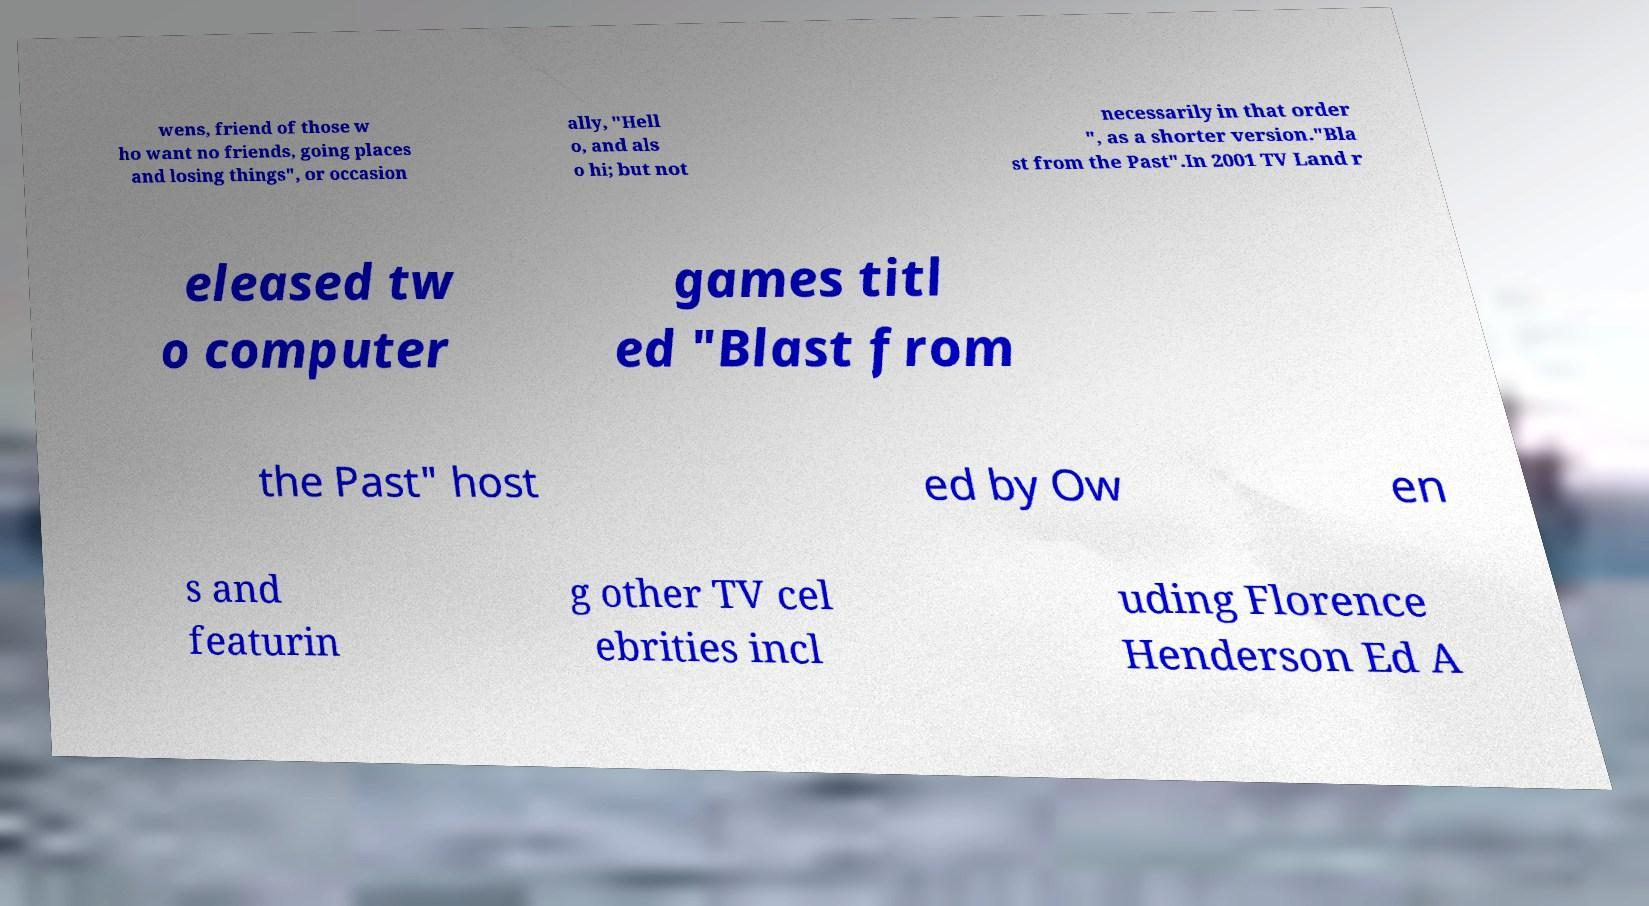Can you read and provide the text displayed in the image?This photo seems to have some interesting text. Can you extract and type it out for me? wens, friend of those w ho want no friends, going places and losing things", or occasion ally, "Hell o, and als o hi; but not necessarily in that order ", as a shorter version."Bla st from the Past".In 2001 TV Land r eleased tw o computer games titl ed "Blast from the Past" host ed by Ow en s and featurin g other TV cel ebrities incl uding Florence Henderson Ed A 